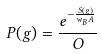<formula> <loc_0><loc_0><loc_500><loc_500>P ( g ) = \frac { e ^ { - \frac { S ( g ) } { w _ { B } A } } } { O }</formula> 